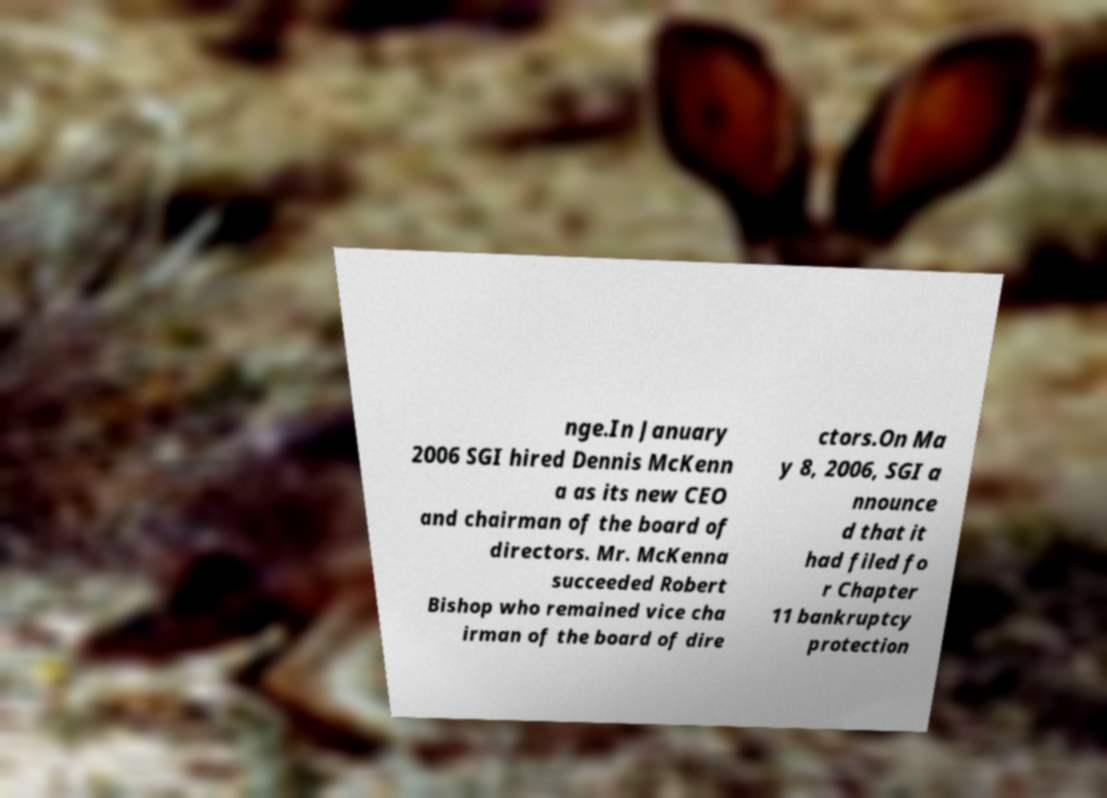Please read and relay the text visible in this image. What does it say? nge.In January 2006 SGI hired Dennis McKenn a as its new CEO and chairman of the board of directors. Mr. McKenna succeeded Robert Bishop who remained vice cha irman of the board of dire ctors.On Ma y 8, 2006, SGI a nnounce d that it had filed fo r Chapter 11 bankruptcy protection 